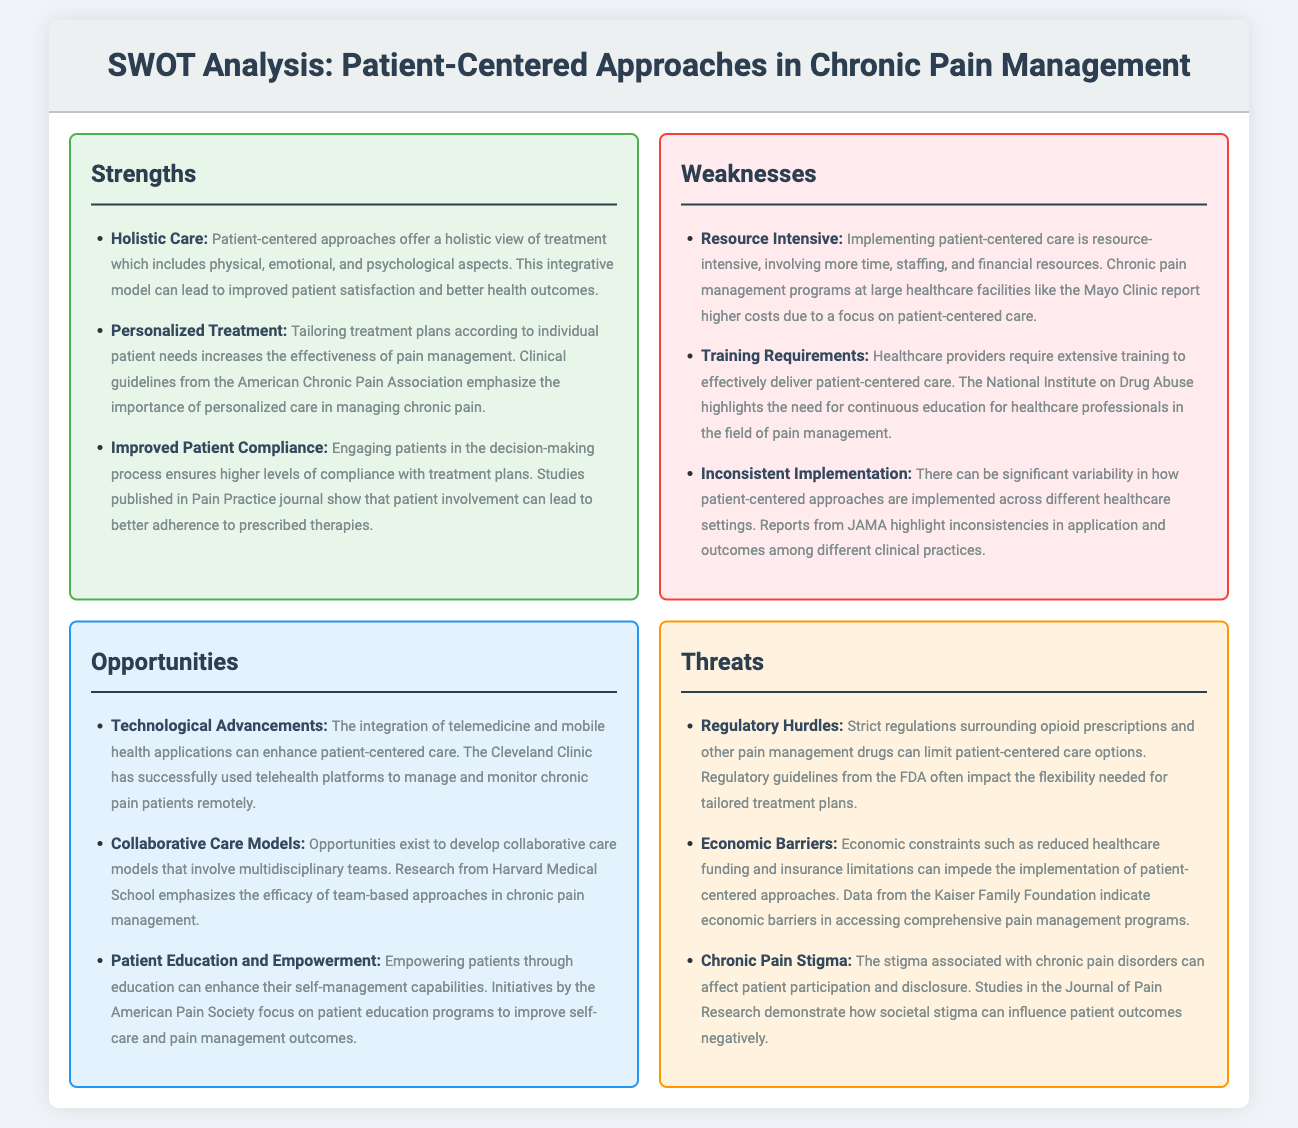What does patient-centered care offer? The document states that patient-centered approaches provide a holistic view of treatment, including physical, emotional, and psychological aspects.
Answer: Holistic Care What is a benefit of personalized treatment in pain management? The document mentions that tailoring treatment plans according to individual needs increases the effectiveness of pain management.
Answer: Effectiveness What can improve patient compliance with treatment plans? Engaging patients in the decision-making process ensures higher levels of compliance with treatment plans according to the document.
Answer: Patient involvement What is a challenge of implementing patient-centered care? The document notes that implementing patient-centered care is resource-intensive, requiring more time, staffing, and financial resources.
Answer: Resource Intensive What kind of training is required for healthcare providers? The document indicates that healthcare providers require extensive training to effectively deliver patient-centered care.
Answer: Extensive training What is an opportunity mentioned for enhancing patient-centered care? The integration of telemedicine and mobile health applications can enhance patient-centered care.
Answer: Technological Advancements How does patient education affect pain management? The document highlights that empowering patients through education can enhance their self-management capabilities.
Answer: Self-management capabilities What threat can limit patient-centered care options? Strict regulations surrounding opioid prescriptions and other pain management drugs are mentioned as a limitation to patient-centered care options.
Answer: Regulatory Hurdles Which economic factors impede patient-centered approaches? The document states that economic constraints like reduced healthcare funding and insurance limitations can impede the implementation of patient-centered approaches.
Answer: Economic barriers 